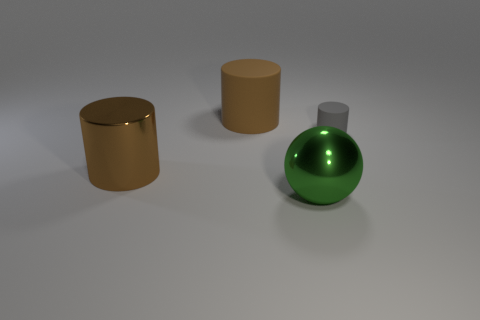Add 4 small gray rubber cylinders. How many objects exist? 8 Subtract all big brown rubber cylinders. How many cylinders are left? 2 Subtract all gray cylinders. How many cylinders are left? 2 Subtract all tiny gray spheres. Subtract all gray matte cylinders. How many objects are left? 3 Add 2 matte cylinders. How many matte cylinders are left? 4 Add 3 large red metal cylinders. How many large red metal cylinders exist? 3 Subtract 0 cyan balls. How many objects are left? 4 Subtract all cylinders. How many objects are left? 1 Subtract 2 cylinders. How many cylinders are left? 1 Subtract all yellow cylinders. Subtract all yellow balls. How many cylinders are left? 3 